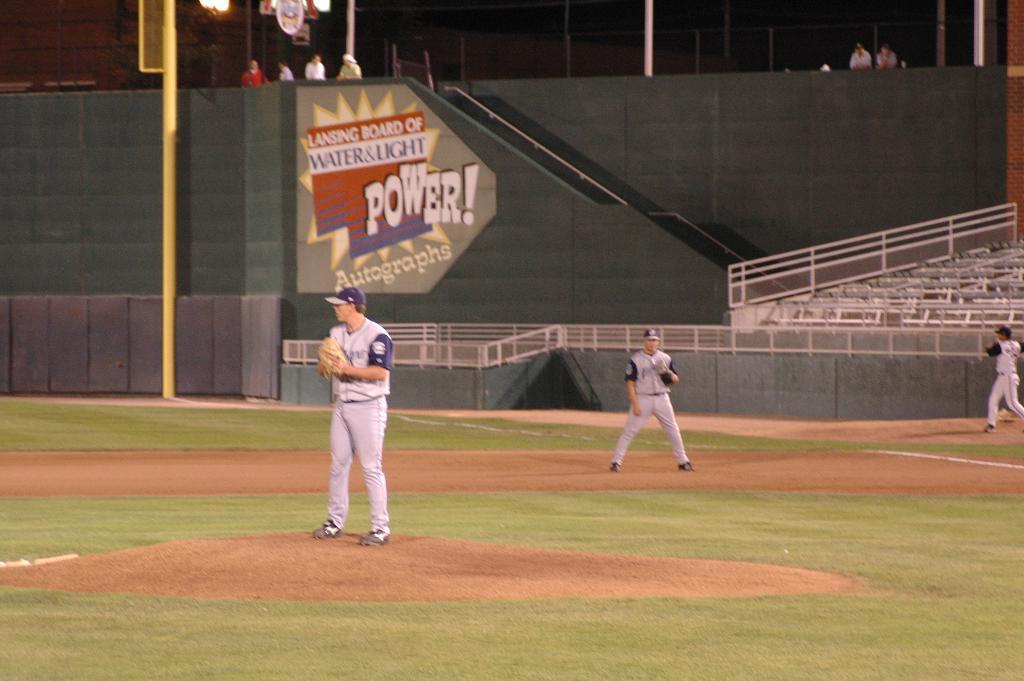What does the sign in the back say?
Offer a terse response. Power. What fan collectible is shown on the sign?
Provide a short and direct response. Autographs. 